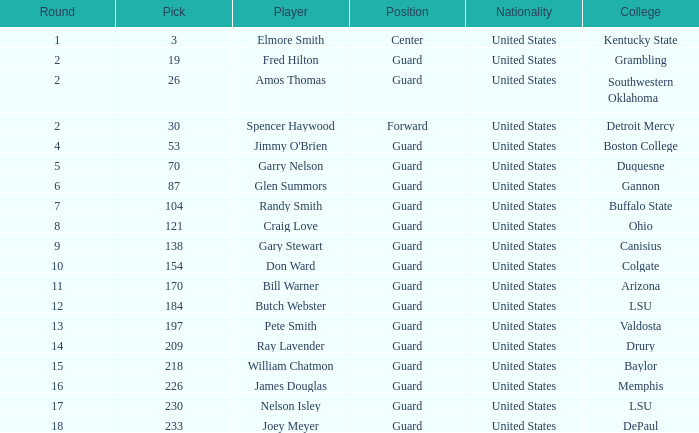What is the overall selection for boston college? 1.0. 